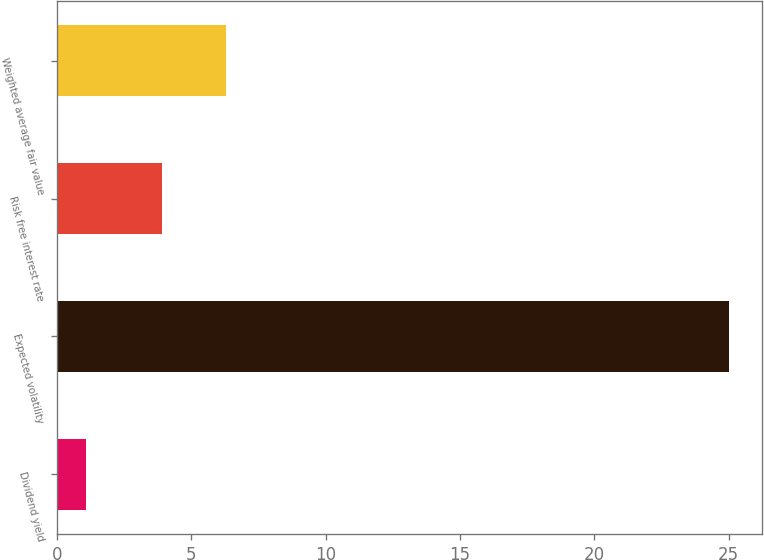Convert chart. <chart><loc_0><loc_0><loc_500><loc_500><bar_chart><fcel>Dividend yield<fcel>Expected volatility<fcel>Risk free interest rate<fcel>Weighted average fair value<nl><fcel>1.1<fcel>25<fcel>3.9<fcel>6.29<nl></chart> 